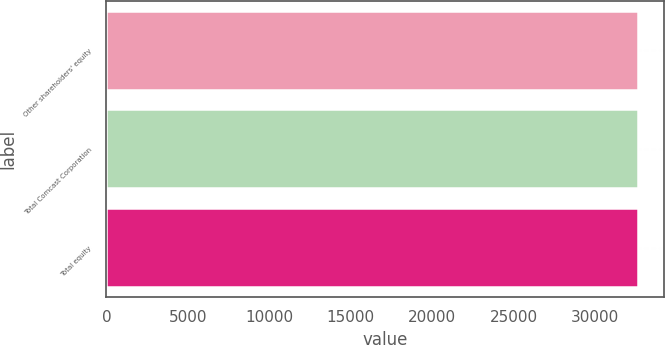Convert chart to OTSL. <chart><loc_0><loc_0><loc_500><loc_500><bar_chart><fcel>Other shareholders' equity<fcel>Total Comcast Corporation<fcel>Total equity<nl><fcel>32622<fcel>32622.1<fcel>32622.2<nl></chart> 